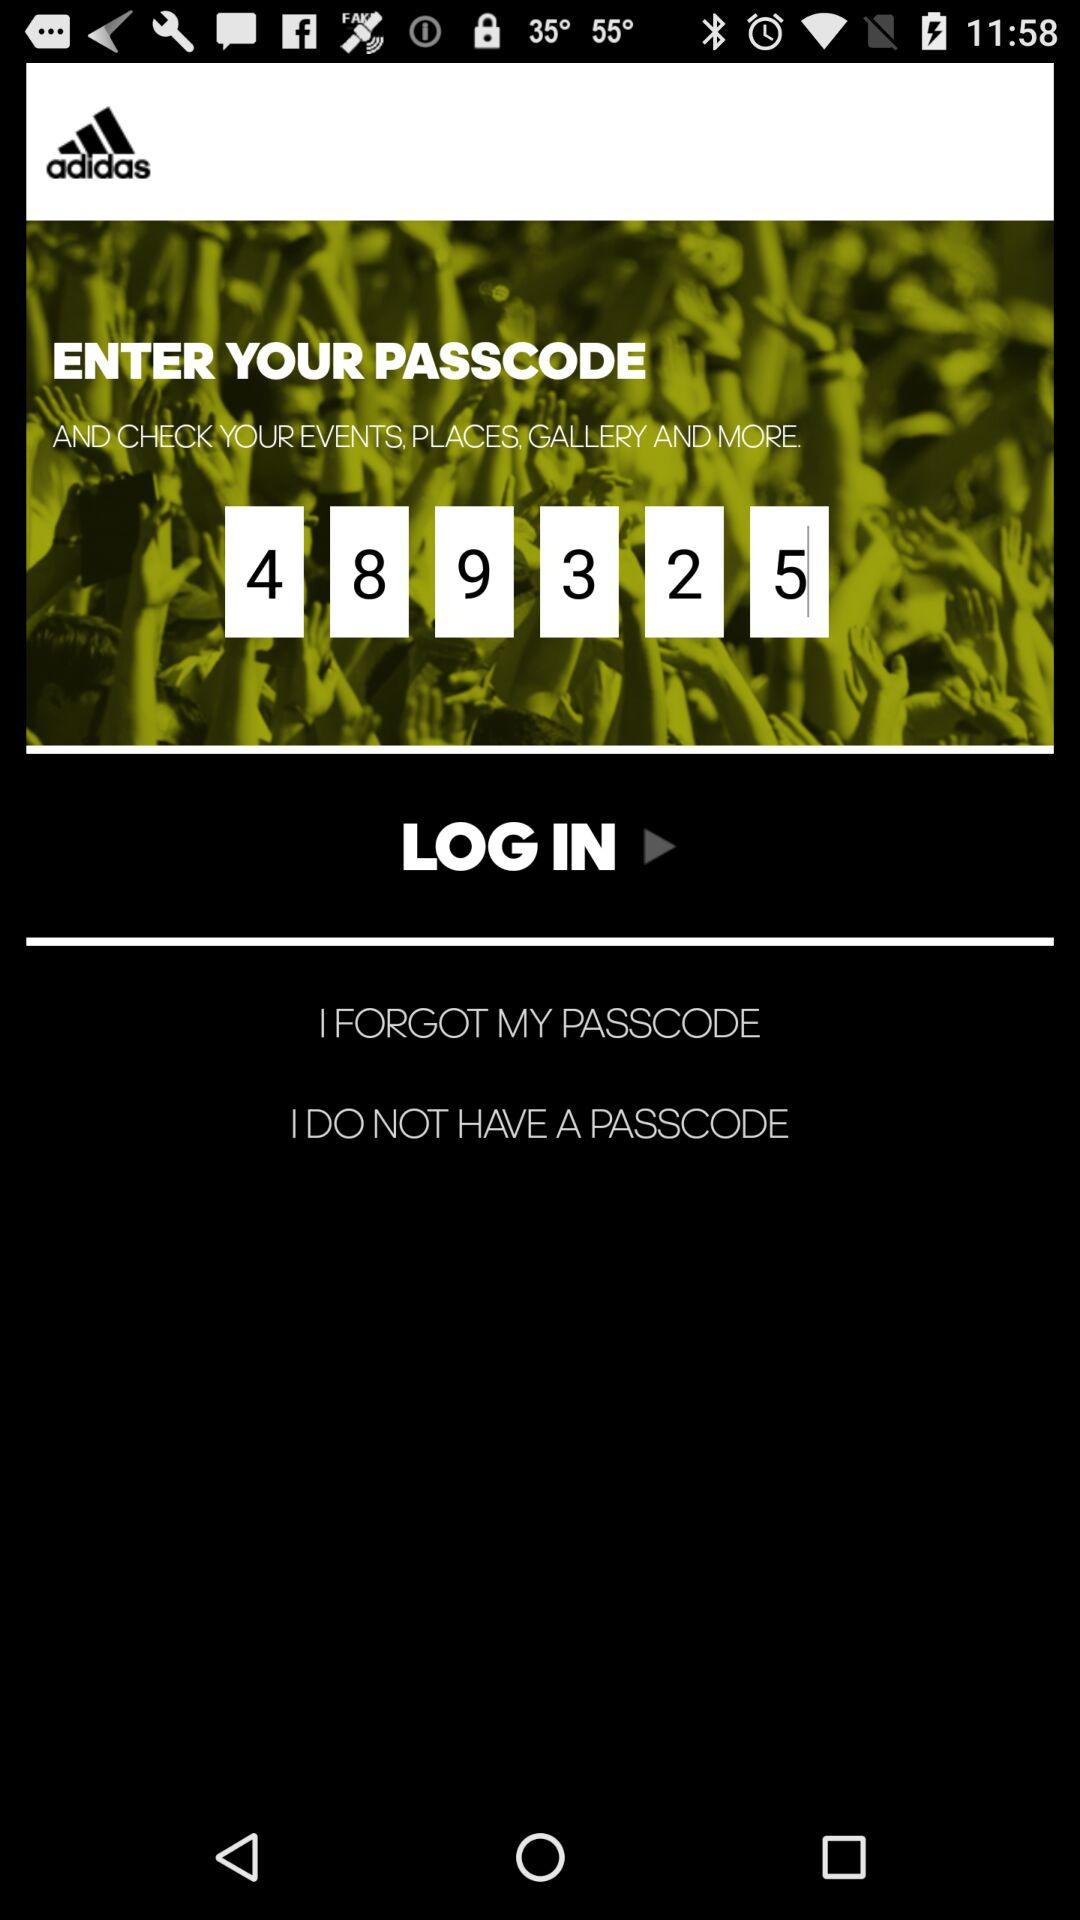How many digits are there in the passcode?
Answer the question using a single word or phrase. 6 